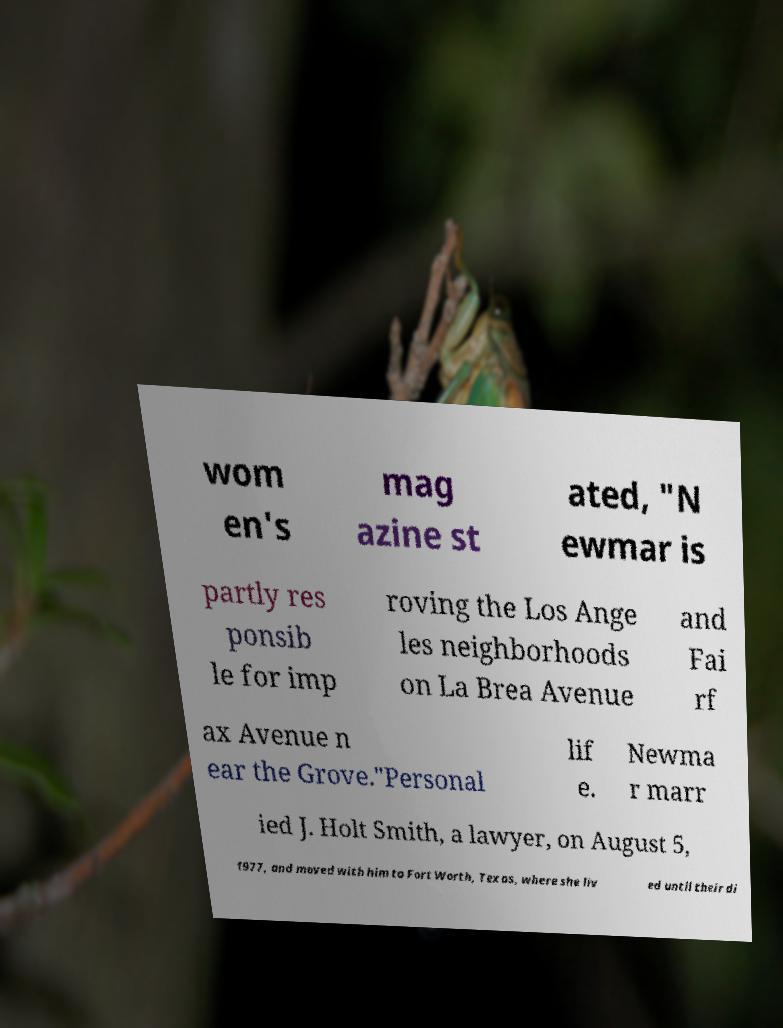Could you assist in decoding the text presented in this image and type it out clearly? wom en's mag azine st ated, "N ewmar is partly res ponsib le for imp roving the Los Ange les neighborhoods on La Brea Avenue and Fai rf ax Avenue n ear the Grove."Personal lif e. Newma r marr ied J. Holt Smith, a lawyer, on August 5, 1977, and moved with him to Fort Worth, Texas, where she liv ed until their di 